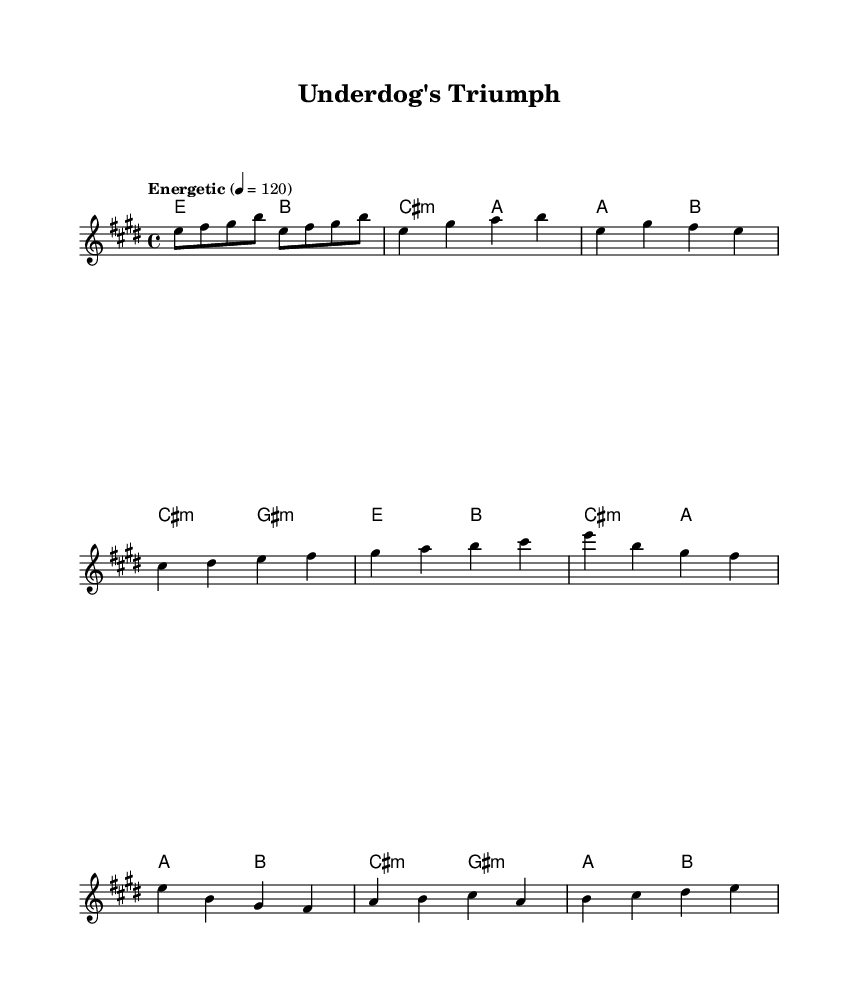What is the key signature of this music? The key signature is E major, which has four sharps (F#, C#, G#, D#). This can be determined by looking at the key specified at the beginning of the score.
Answer: E major What is the time signature of this music? The time signature is 4/4, as indicated at the beginning of the score. This means there are four beats in each measure, and the quarter note gets one beat.
Answer: 4/4 What is the tempo marking for this piece? The tempo marking is "Energetic" and specifies a tempo of quarter note = 120 beats per minute, which gives it a lively pace. This is found prominently at the start of the score.
Answer: Energetic How many measures are in the chorus section? The chorus section consists of two measures, both indicated by the musical notation that follows the pre-chorus. By counting the bars in this segment, we can determine the measure count.
Answer: 2 What type of song structure is used in this music? The structure follows a common song format: Verse - Pre-Chorus - Chorus. This is typical for motivational rock anthems, as it helps build intensity and emotion, reflecting the theme of overcoming adversity. This structure can be inferred by ordering the sections listed in the lyrics.
Answer: Verse - Pre-Chorus - Chorus Which phrase in the chorus signifies a call to action? The phrase "Rise up, underdog, Your time has come," serves as a motivational rallying cry, explicitly encouraging the listener to take action. This is determined by recognizing thematic elements in the lyrics.
Answer: "Rise up, underdog, Your time has come." 